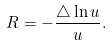<formula> <loc_0><loc_0><loc_500><loc_500>R = - \frac { \triangle \ln u } { u } .</formula> 